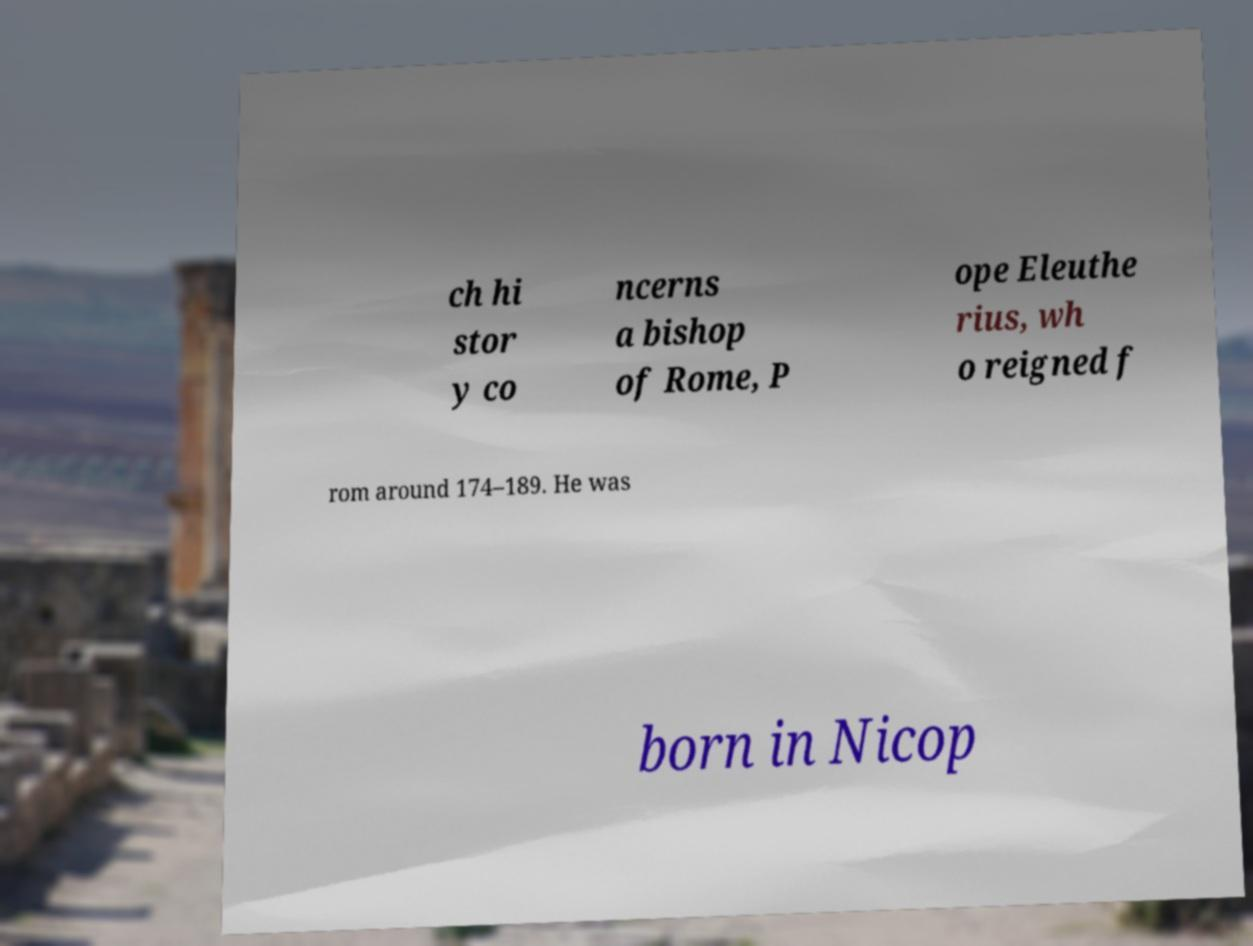Please identify and transcribe the text found in this image. ch hi stor y co ncerns a bishop of Rome, P ope Eleuthe rius, wh o reigned f rom around 174–189. He was born in Nicop 